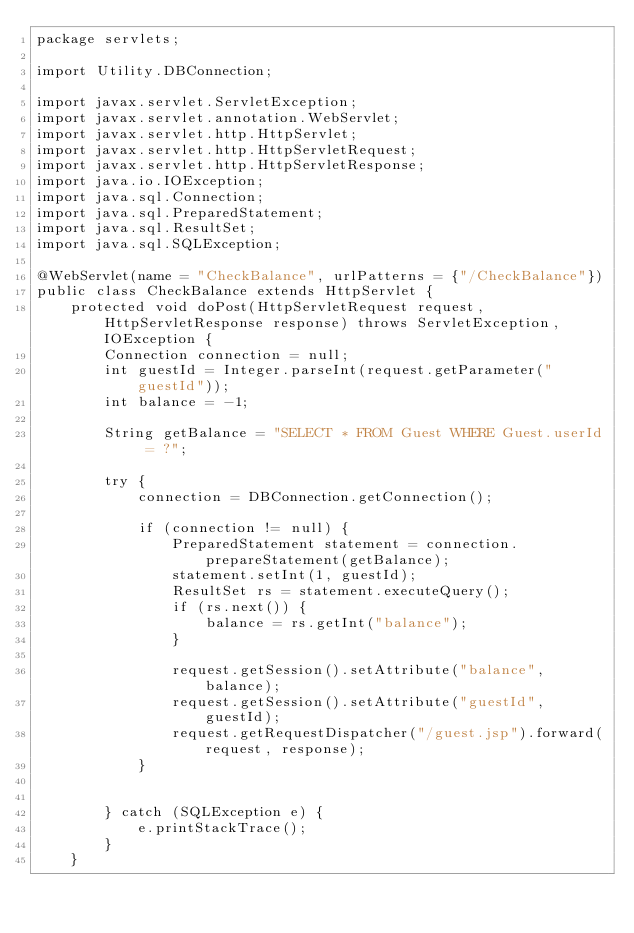Convert code to text. <code><loc_0><loc_0><loc_500><loc_500><_Java_>package servlets;

import Utility.DBConnection;

import javax.servlet.ServletException;
import javax.servlet.annotation.WebServlet;
import javax.servlet.http.HttpServlet;
import javax.servlet.http.HttpServletRequest;
import javax.servlet.http.HttpServletResponse;
import java.io.IOException;
import java.sql.Connection;
import java.sql.PreparedStatement;
import java.sql.ResultSet;
import java.sql.SQLException;

@WebServlet(name = "CheckBalance", urlPatterns = {"/CheckBalance"})
public class CheckBalance extends HttpServlet {
    protected void doPost(HttpServletRequest request, HttpServletResponse response) throws ServletException, IOException {
        Connection connection = null;
        int guestId = Integer.parseInt(request.getParameter("guestId"));
        int balance = -1;

        String getBalance = "SELECT * FROM Guest WHERE Guest.userId = ?";

        try {
            connection = DBConnection.getConnection();

            if (connection != null) {
                PreparedStatement statement = connection.prepareStatement(getBalance);
                statement.setInt(1, guestId);
                ResultSet rs = statement.executeQuery();
                if (rs.next()) {
                    balance = rs.getInt("balance");
                }

                request.getSession().setAttribute("balance", balance);
                request.getSession().setAttribute("guestId", guestId);
                request.getRequestDispatcher("/guest.jsp").forward(request, response);
            }


        } catch (SQLException e) {
            e.printStackTrace();
        }
    }
</code> 